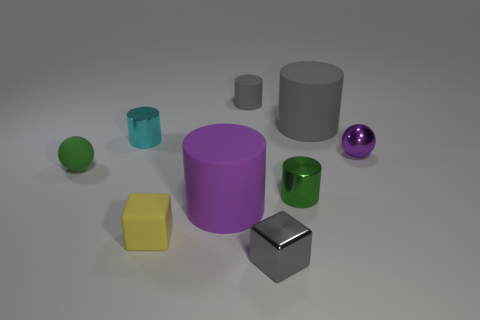The purple metal thing that is the same size as the cyan cylinder is what shape? The purple object is indeed spherical in shape, resembling a standard ball with a reflective surface that is consistent with metallic materials. 